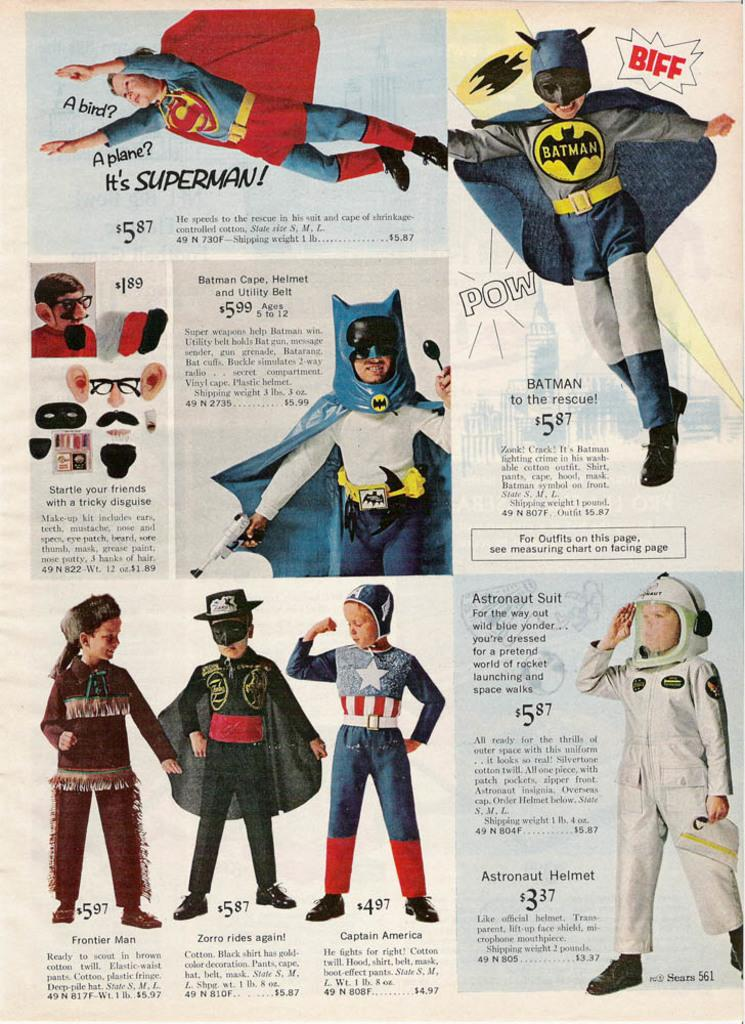Who or what is present in the image? There are people in the image. What are the people wearing? The people are wearing fancy dress. Is there any text associated with the image? Yes, there is text written beside and below the people. What type of hair style can be seen on the people in the image? There is no specific hair style mentioned in the facts provided, so we cannot determine the type of hair style from the image. Is there a volleyball game happening in the image? There is no mention of a volleyball game or any sports-related activity in the image. Can you tell me if the people in the image are related to an uncle? The facts provided do not mention any familial relationships, so we cannot determine if the people in the image are related to an uncle. 